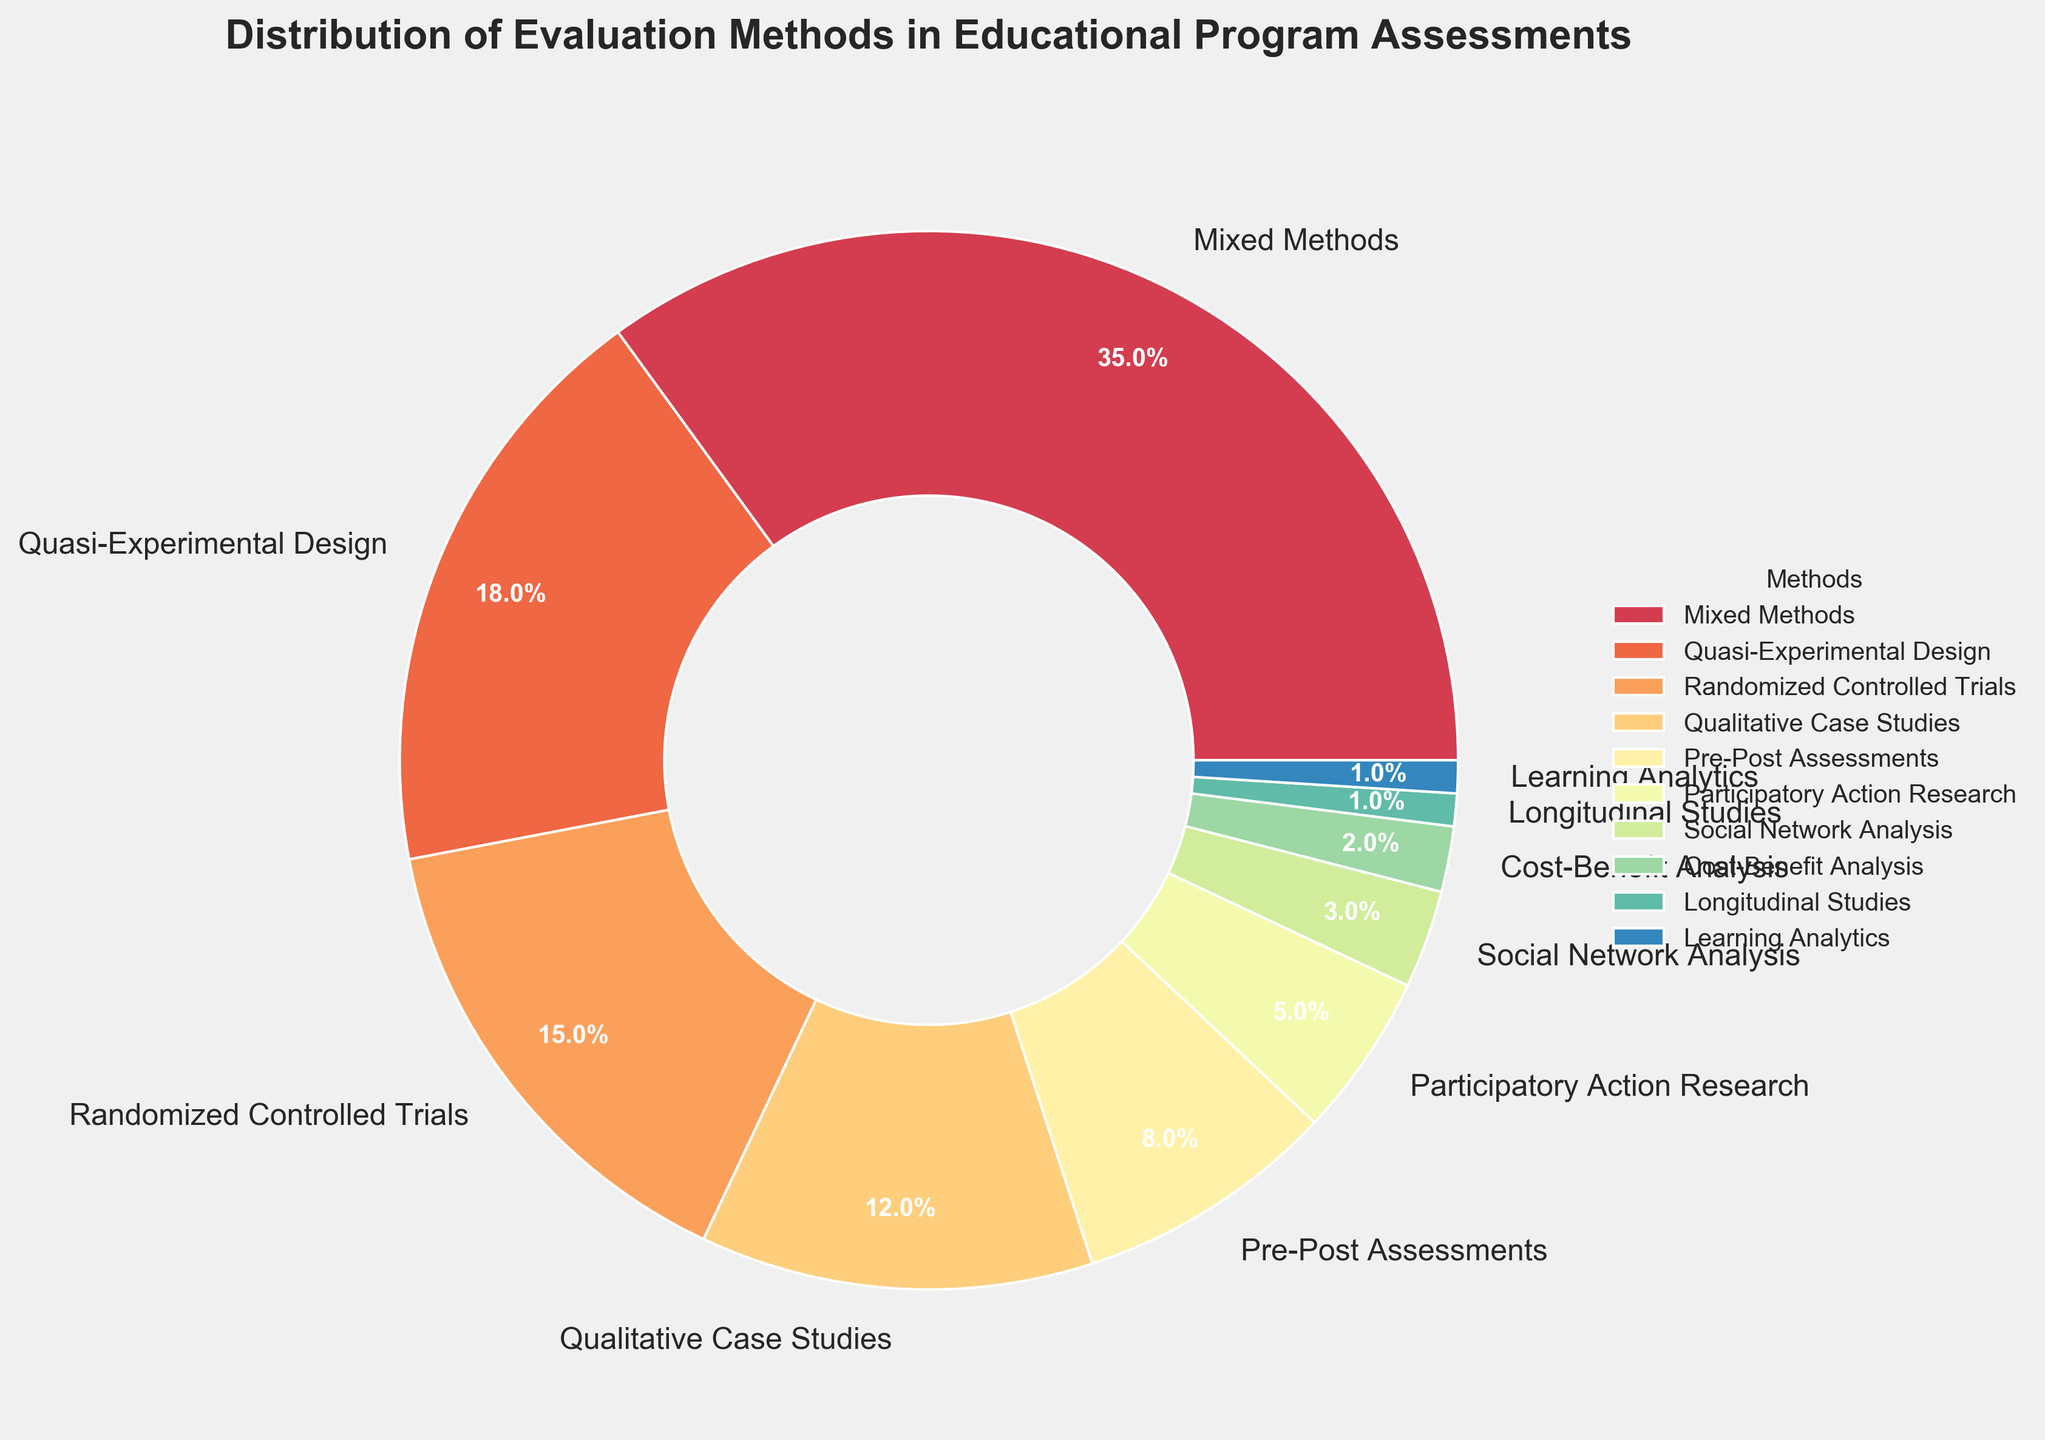Which evaluation method has the highest percentage in the pie chart? The pie chart shows various evaluation methods with their respective percentages. The method with the largest slice and labeled percentage is 'Mixed Methods' at 35%.
Answer: Mixed Methods Which method is least used according to the pie chart? Examination of the pie chart reveals the smallest slice, labeled 'Learning Analytics', at 1%.
Answer: Learning Analytics How much greater is the percentage of Mixed Methods compared to Randomized Controlled Trials? The pie chart shows Mixed Methods at 35% and Randomized Controlled Trials at 15%. The difference is calculated as 35% - 15% = 20%.
Answer: 20% If we combined the percentages of Qualitative Case Studies and Pre-Post Assessments, what would be their total percentage? According to the pie chart, Qualitative Case Studies are at 12% and Pre-Post Assessments are at 8%. Their combined percentage is 12% + 8% = 20%.
Answer: 20% What is the average percentage of the three least used methods? The three least used methods are Learning Analytics (1%), Longitudinal Studies (1%), and Cost-Benefit Analysis (2%). Their average is calculated as (1% + 1% + 2%)/3 = 4%/3 ≈ 1.33%.
Answer: 1.33% Which evaluation methods have a percentage of at least 10%? The pie chart shows methods with at least 10% each as: Mixed Methods (35%), Quasi-Experimental Design (18%), Randomized Controlled Trials (15%), and Qualitative Case Studies (12%).
Answer: Mixed Methods, Quasi-Experimental Design, Randomized Controlled Trials, Qualitative Case Studies How many methods have a lower percentage than Participatory Action Research? Participatory Action Research is at 5%. The methods with lower percentages are Social Network Analysis (3%), Cost-Benefit Analysis (2%), Longitudinal Studies (1%), and Learning Analytics (1%). Four methods have a lower percentage.
Answer: 4 Is the sum of the percentages for Mixed Methods and Quasi-Experimental Design greater than 50%? Mixed Methods is at 35% and Quasi-Experimental Design is at 18%. Their sum is 35% + 18% = 53%, which is greater than 50%.
Answer: Yes Which two methods combined have a total percentage closest to 20%? Examining pairs of percentages, Participatory Action Research (5%) and Social Network Analysis (3%) together are 8%, Pre-Post Assessments (8%) and Participatory Action Research (5%) together are 13%, but Qualitative Case Studies (12%) and Pre-Post Assessments (8%) together are closest at 20%.
Answer: Qualitative Case Studies and Pre-Post Assessments 